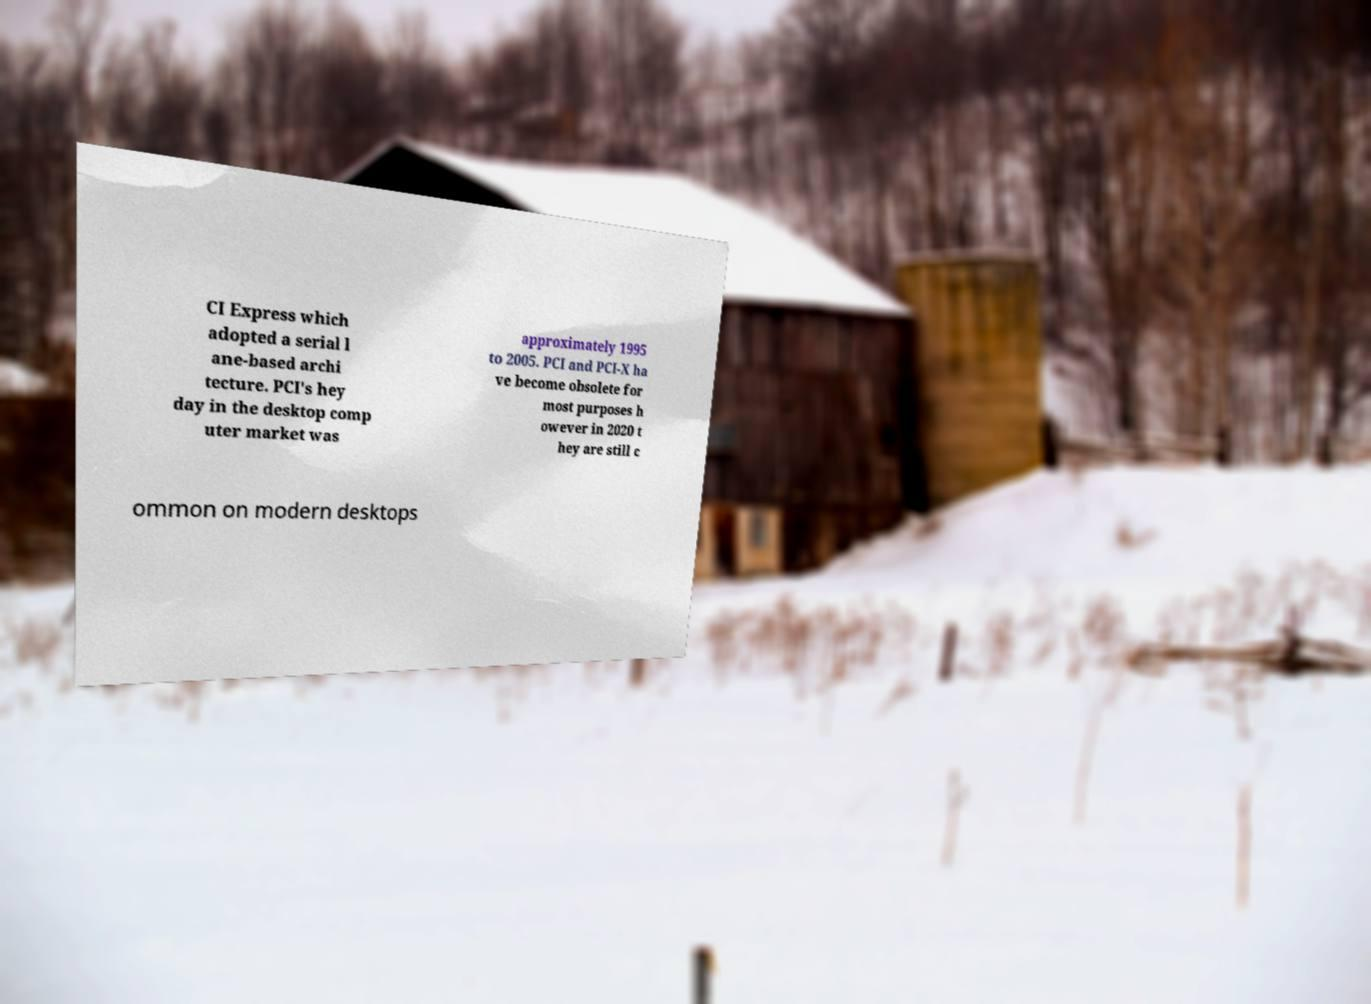Can you read and provide the text displayed in the image?This photo seems to have some interesting text. Can you extract and type it out for me? CI Express which adopted a serial l ane-based archi tecture. PCI's hey day in the desktop comp uter market was approximately 1995 to 2005. PCI and PCI-X ha ve become obsolete for most purposes h owever in 2020 t hey are still c ommon on modern desktops 